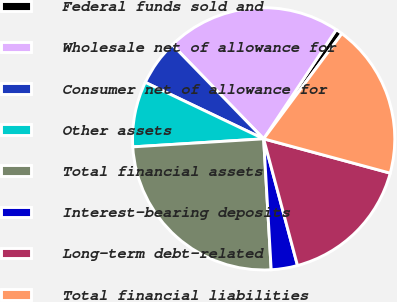Convert chart. <chart><loc_0><loc_0><loc_500><loc_500><pie_chart><fcel>Federal funds sold and<fcel>Wholesale net of allowance for<fcel>Consumer net of allowance for<fcel>Other assets<fcel>Total financial assets<fcel>Interest-bearing deposits<fcel>Long-term debt-related<fcel>Total financial liabilities<nl><fcel>0.83%<fcel>21.61%<fcel>5.65%<fcel>8.06%<fcel>24.94%<fcel>3.24%<fcel>16.63%<fcel>19.04%<nl></chart> 